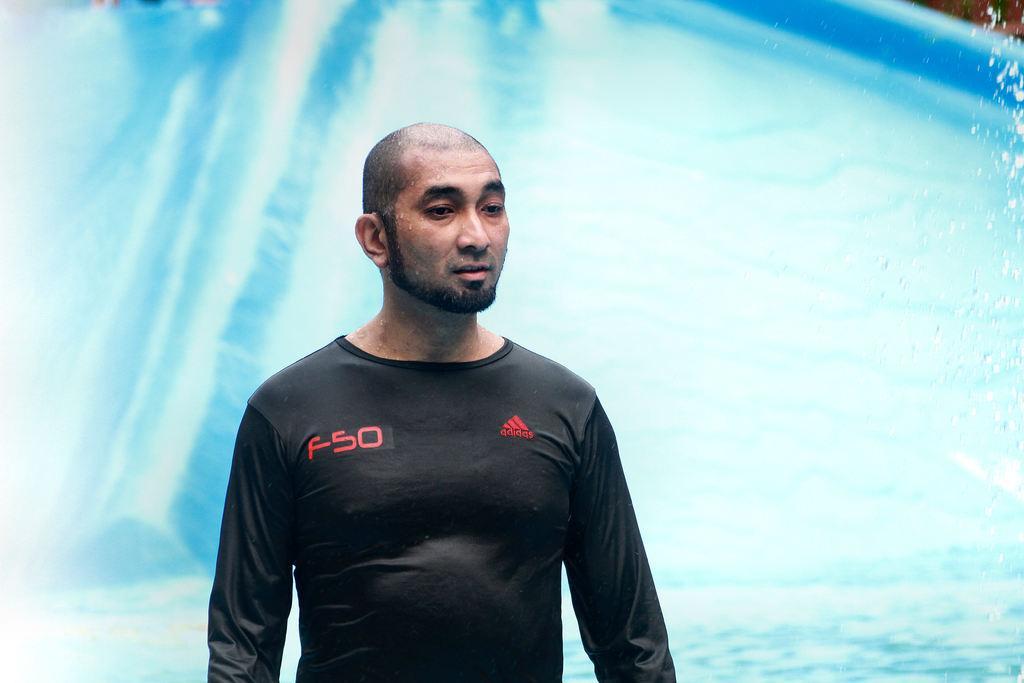Describe this image in one or two sentences. In the image in the center, we can see one person and he is in black color t shirt. In the background there is a slope and water. 